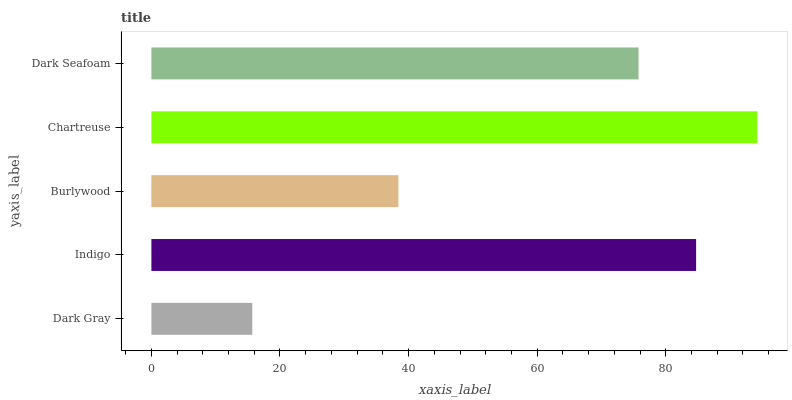Is Dark Gray the minimum?
Answer yes or no. Yes. Is Chartreuse the maximum?
Answer yes or no. Yes. Is Indigo the minimum?
Answer yes or no. No. Is Indigo the maximum?
Answer yes or no. No. Is Indigo greater than Dark Gray?
Answer yes or no. Yes. Is Dark Gray less than Indigo?
Answer yes or no. Yes. Is Dark Gray greater than Indigo?
Answer yes or no. No. Is Indigo less than Dark Gray?
Answer yes or no. No. Is Dark Seafoam the high median?
Answer yes or no. Yes. Is Dark Seafoam the low median?
Answer yes or no. Yes. Is Dark Gray the high median?
Answer yes or no. No. Is Chartreuse the low median?
Answer yes or no. No. 